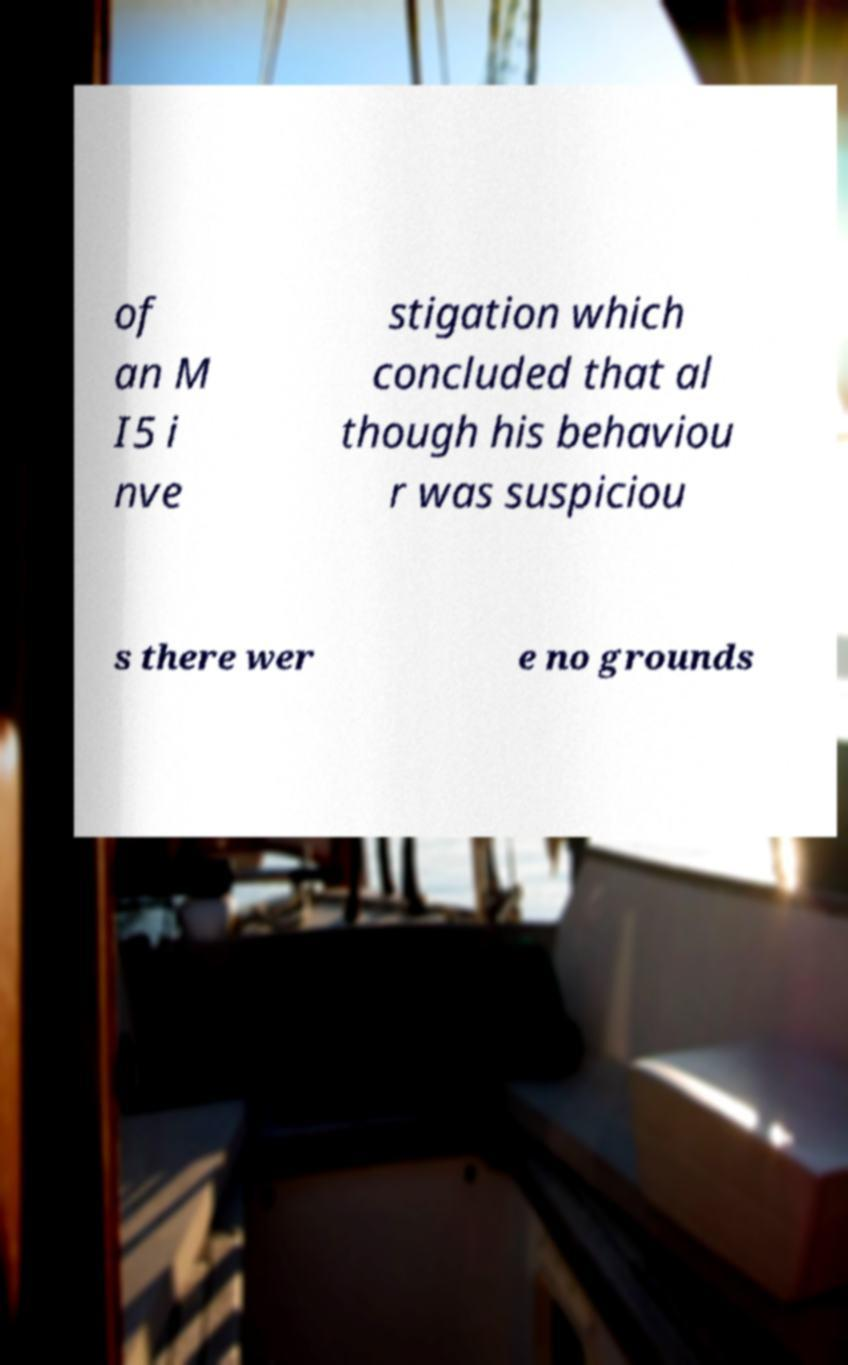Can you accurately transcribe the text from the provided image for me? of an M I5 i nve stigation which concluded that al though his behaviou r was suspiciou s there wer e no grounds 